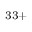<formula> <loc_0><loc_0><loc_500><loc_500>^ { 3 3 + }</formula> 